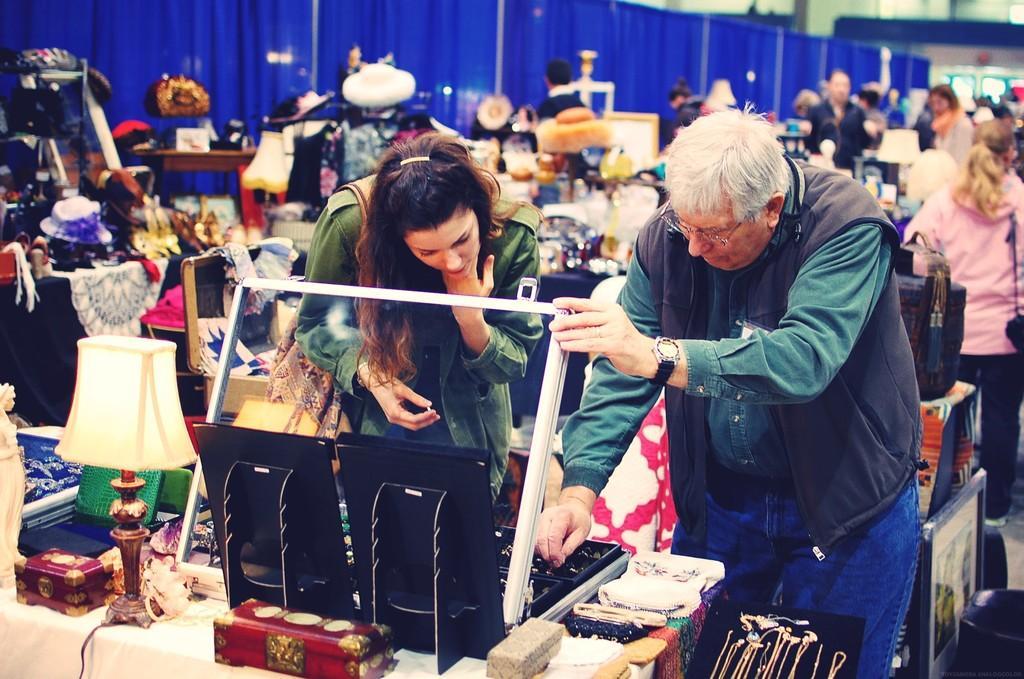Can you describe this image briefly? On the left side of the image there is a man with spectacles and watch on his hand. Beside him there is a lady standing. In front of them there is a table with statue, lamp, boxes and some other items on the table. In the background there is a blue wall. And behind them there are few people and also there are many other items. And there is a blur background. 